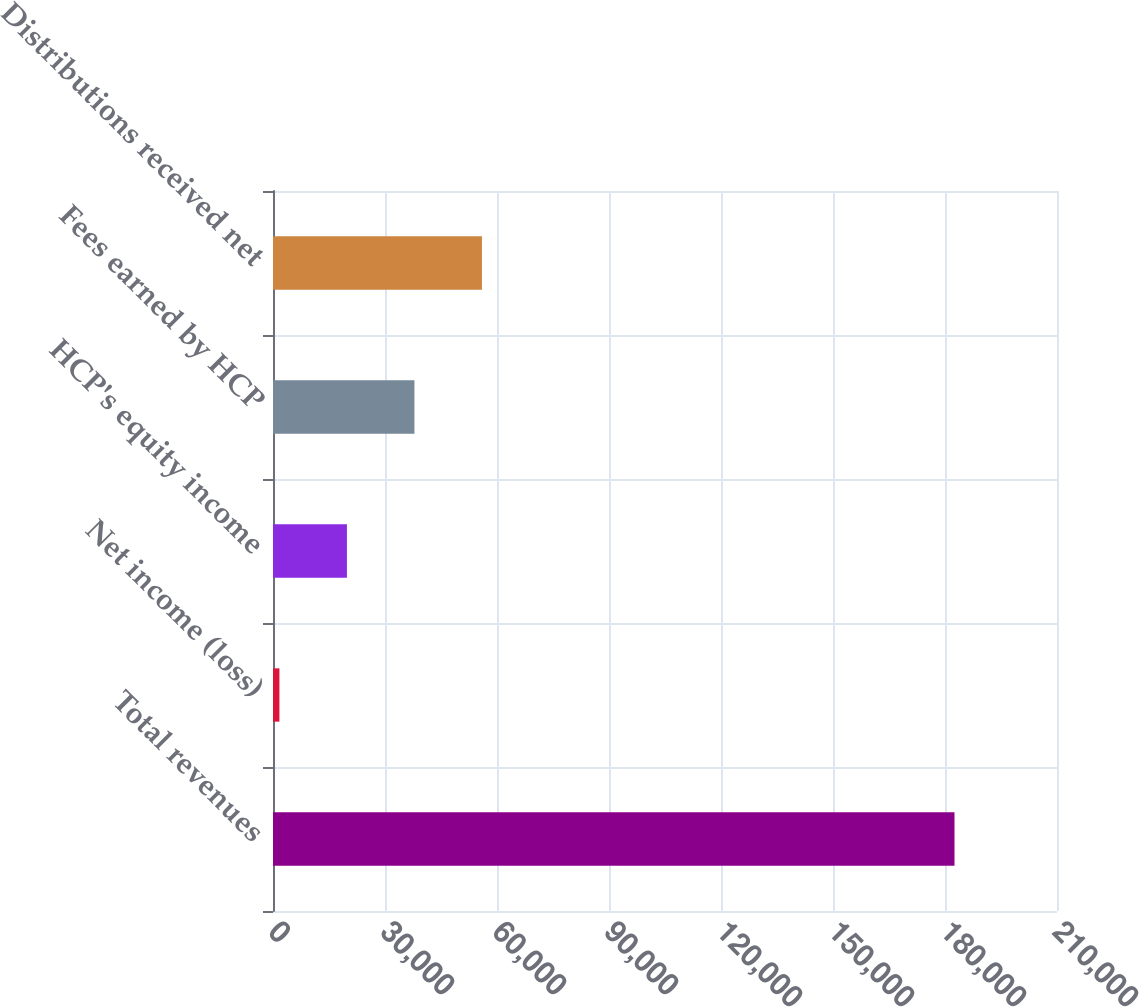Convert chart to OTSL. <chart><loc_0><loc_0><loc_500><loc_500><bar_chart><fcel>Total revenues<fcel>Net income (loss)<fcel>HCP's equity income<fcel>Fees earned by HCP<fcel>Distributions received net<nl><fcel>182543<fcel>1720<fcel>19802.3<fcel>37884.6<fcel>55966.9<nl></chart> 